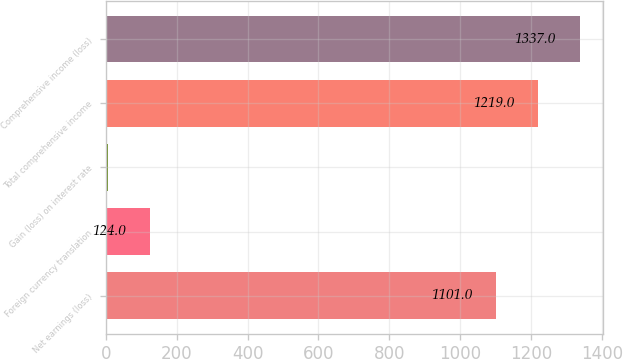<chart> <loc_0><loc_0><loc_500><loc_500><bar_chart><fcel>Net earnings (loss)<fcel>Foreign currency translation<fcel>Gain (loss) on interest rate<fcel>Total comprehensive income<fcel>Comprehensive income (loss)<nl><fcel>1101<fcel>124<fcel>6<fcel>1219<fcel>1337<nl></chart> 